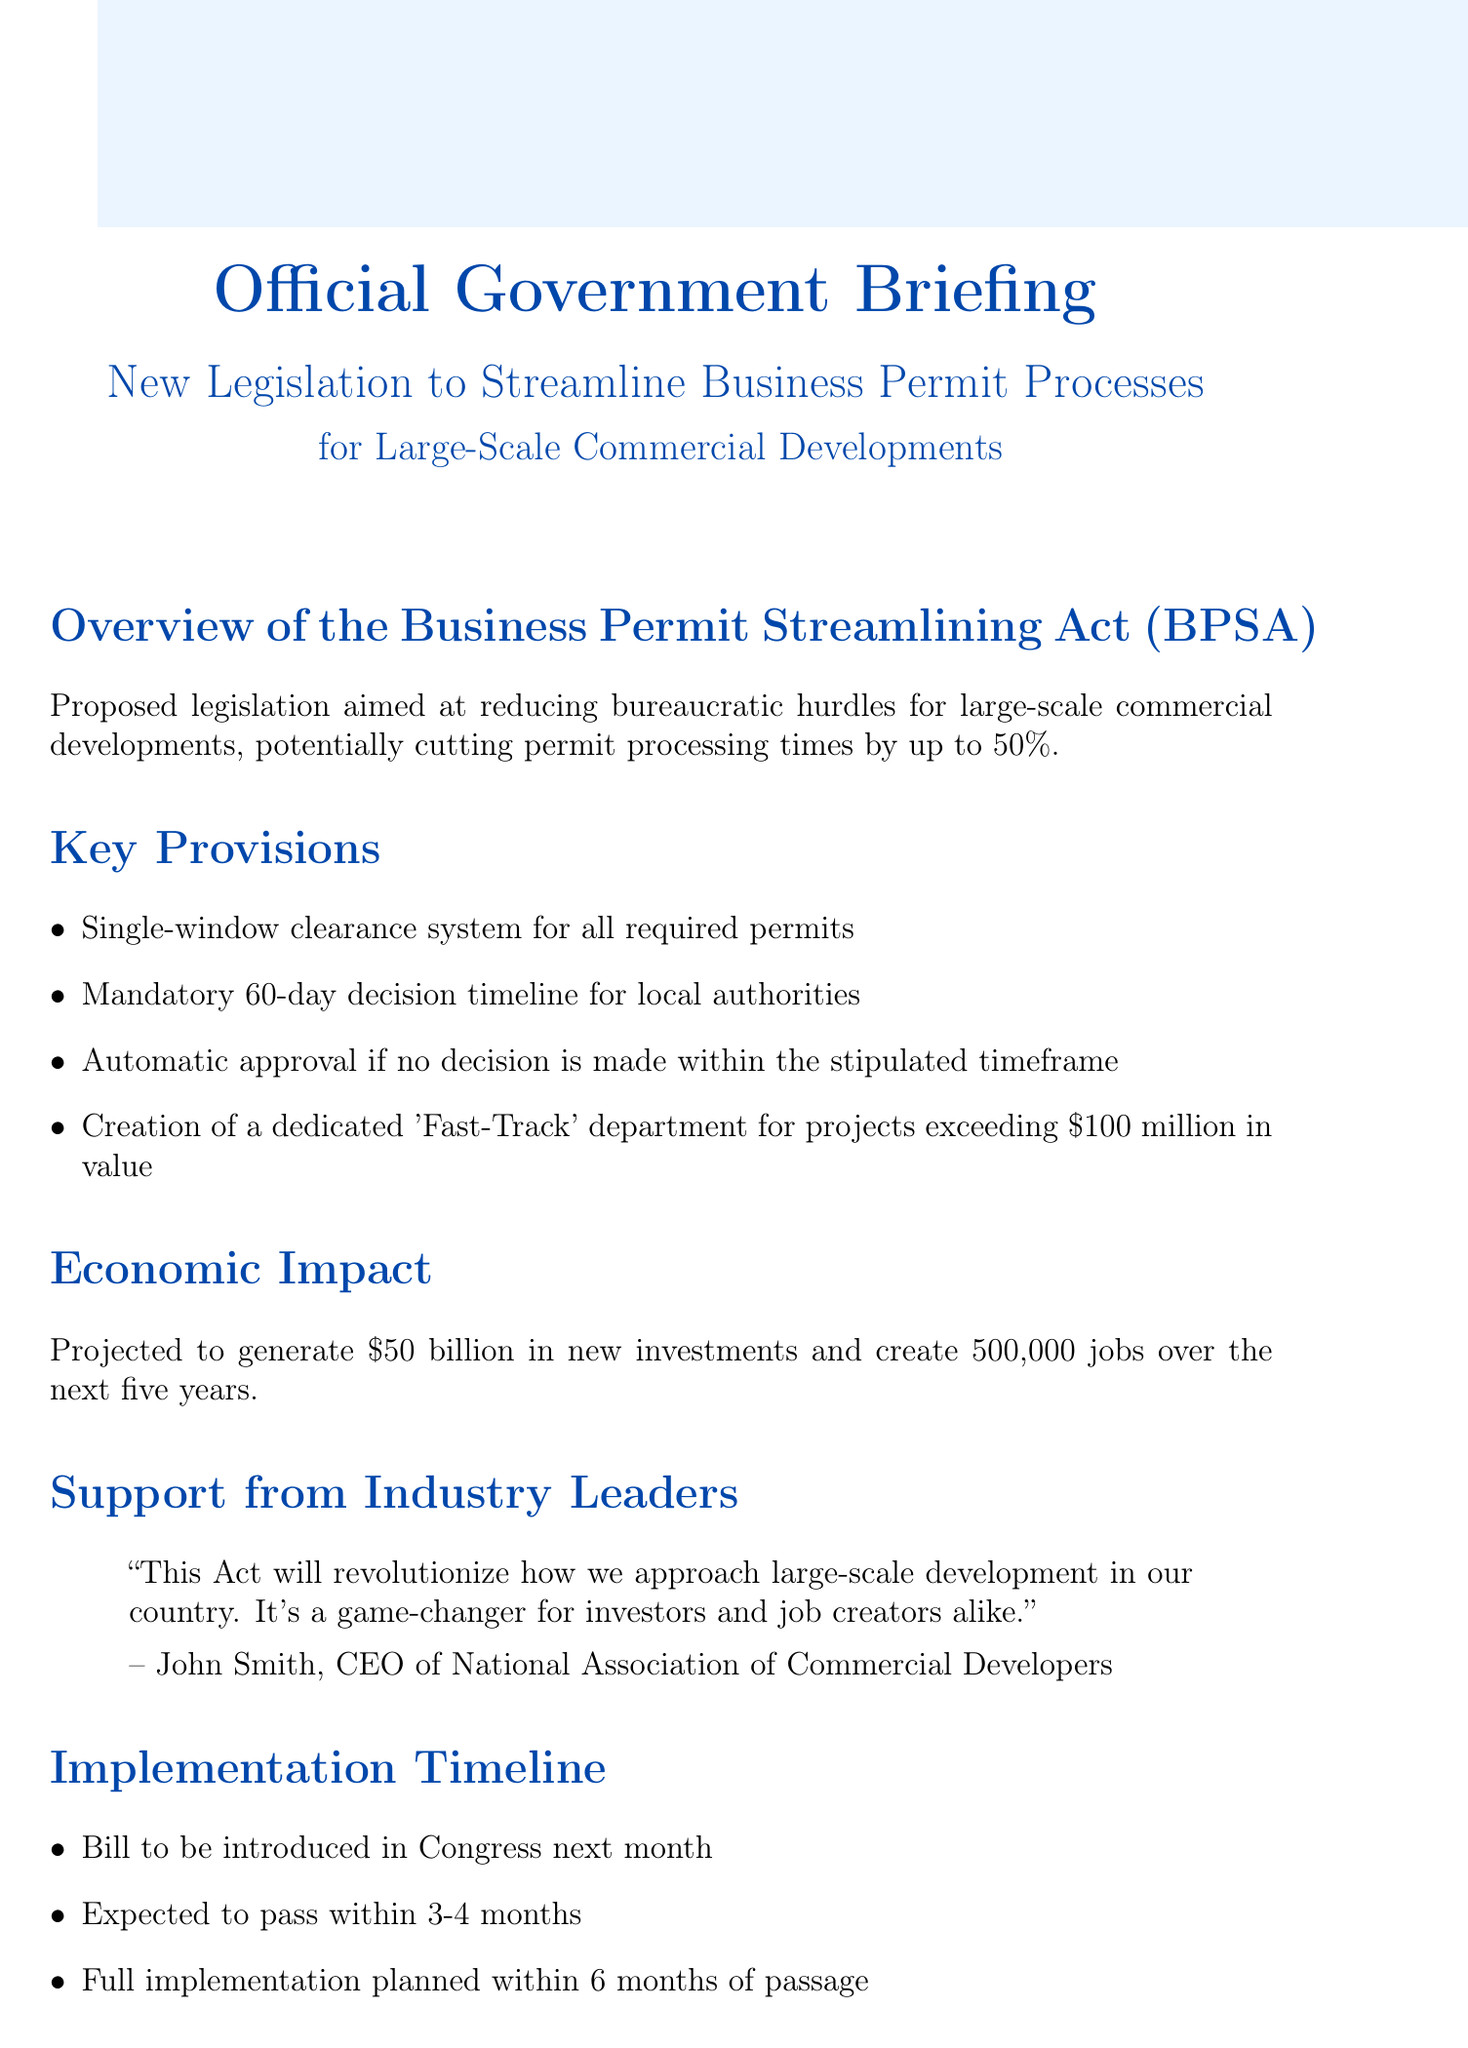What is the name of the legislation? The legislation discussed in the document is termed the Business Permit Streamlining Act (BPSA).
Answer: Business Permit Streamlining Act (BPSA) What is the projected job creation in five years? The document states that the legislation is projected to create 500,000 jobs over the next five years.
Answer: 500,000 What is the mandatory decision timeline for local authorities? According to the document, local authorities are given a mandatory 60-day decision timeline for permits.
Answer: 60 days What is the expected investment generation? The document projects that the new legislation will generate $50 billion in new investments.
Answer: $50 billion What type of department will be created for large projects? The document mentions the creation of a dedicated 'Fast-Track' department for projects exceeding $100 million in value.
Answer: 'Fast-Track' department What is the incentive for companies investing over $500 million? Companies investing over $500 million will receive tax breaks as an incentive outlined in the document.
Answer: Tax breaks How long is the expected passage time for the bill? The document indicates that the legislation is expected to pass within 3-4 months after being introduced in Congress.
Answer: 3-4 months What is the required job creation for subsidized land acquisition? The document specifies that projects creating more than 1000 jobs can receive subsidized land acquisition.
Answer: More than 1000 jobs 